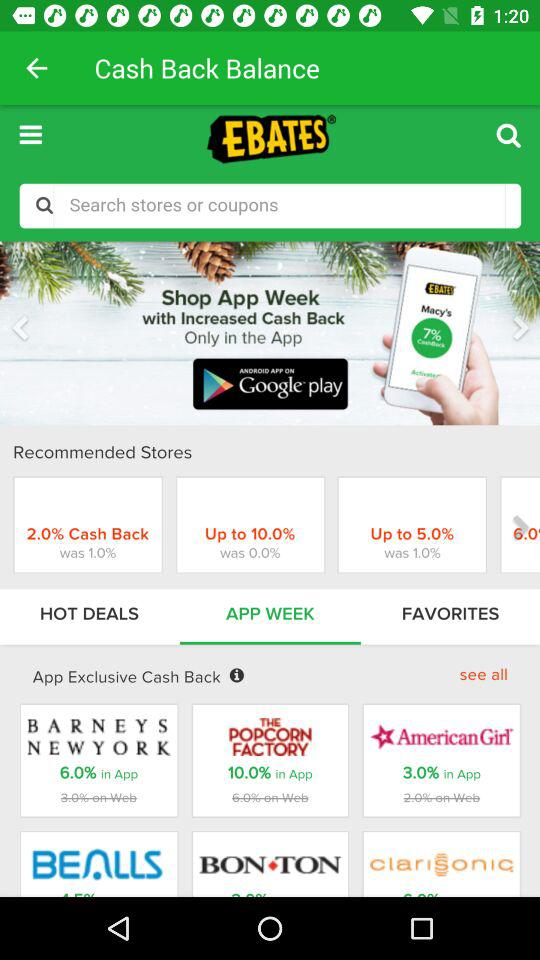Which category is chosen in "Cash Back Balance"? In "Cash Back Balance", "APP WEEK" is chosen. 